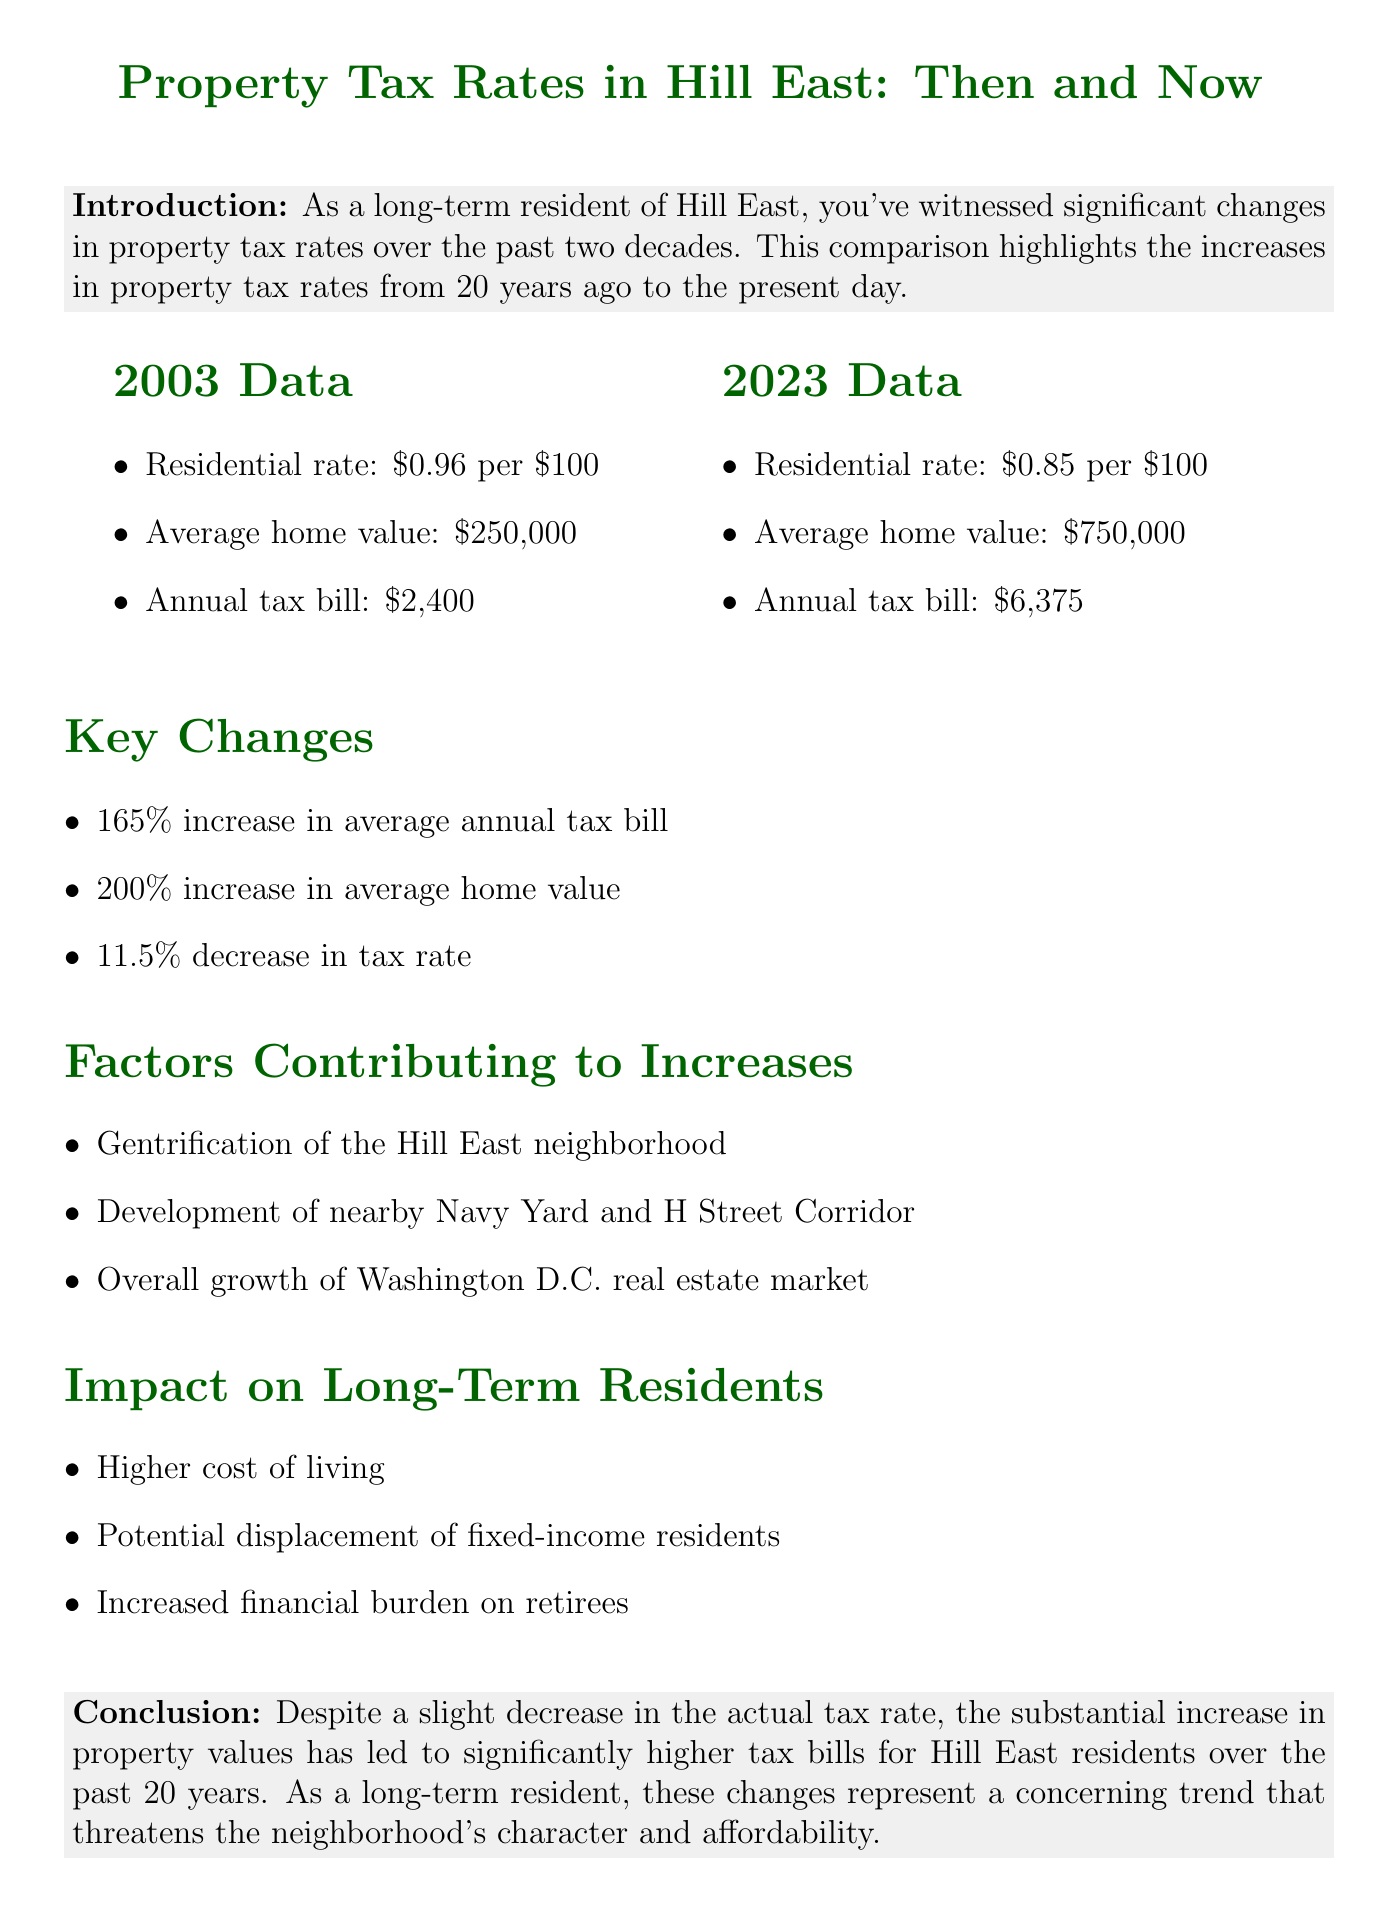what was the residential tax rate in 2003? The residential tax rate in 2003 is stated in the historical data section of the document.
Answer: $0.96 per $100 what is the average home value in 2023? The average home value in 2023 is found in the current data section of the document.
Answer: $750,000 how much has the average annual tax bill increased? To determine the increase, compare the annual tax bill from 2003 to 2023, noted in the key changes section.
Answer: 165% what factors contributed to the increase in property tax rates? This information is listed in the section discussing factors contributing to increases.
Answer: Gentrification of the Hill East neighborhood how much did the average home value increase over 20 years? The document specifies a percentage increase of the average home value over time in the key changes section.
Answer: 200% what is the conclusion about property tax rates? The conclusion summarizes the overall finding regarding tax rates and their implications.
Answer: Higher tax bills for residents what year does the document compare to the present? The document compares property tax data from two specific years mentioned in the introduction.
Answer: 2003 what is the impact mentioned for long-term residents? This information is discussed in the section focusing on the impact on long-term residents.
Answer: Higher cost of living 